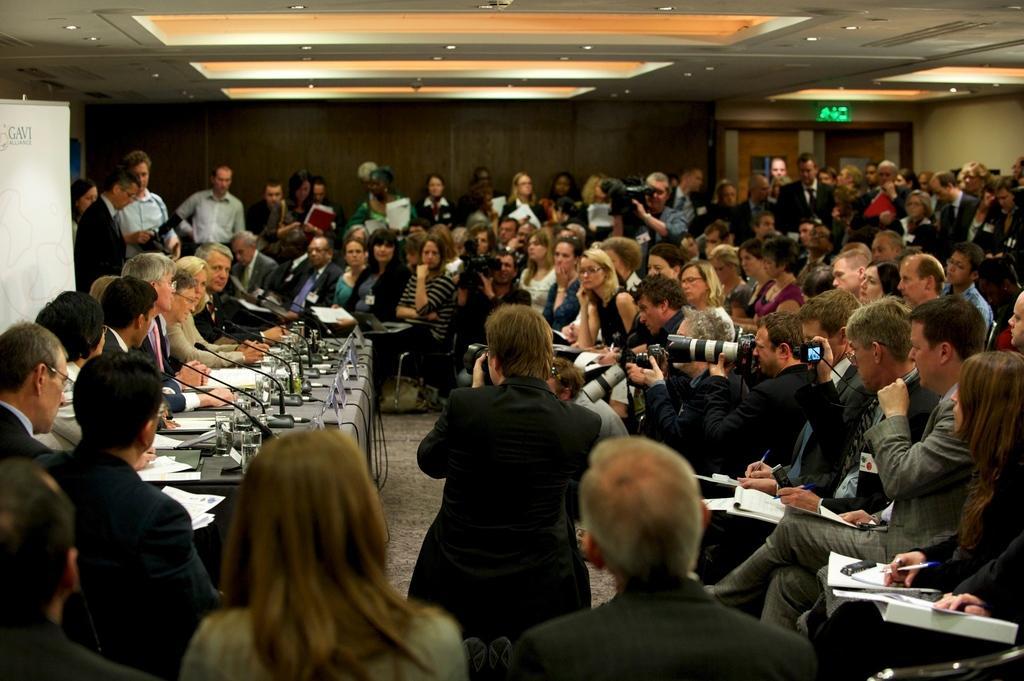Could you give a brief overview of what you see in this image? In this image in the middle there is a man, he wears a suit, he is holding a camera. At the bottom there is a man, he wears a suit and there is a woman, she wears a dress. In the middle there are many people. On the left there is a table on that there are mice, glasses, papers, cables and cloth. In the middle there are people, posters, lights, roof and wall. 